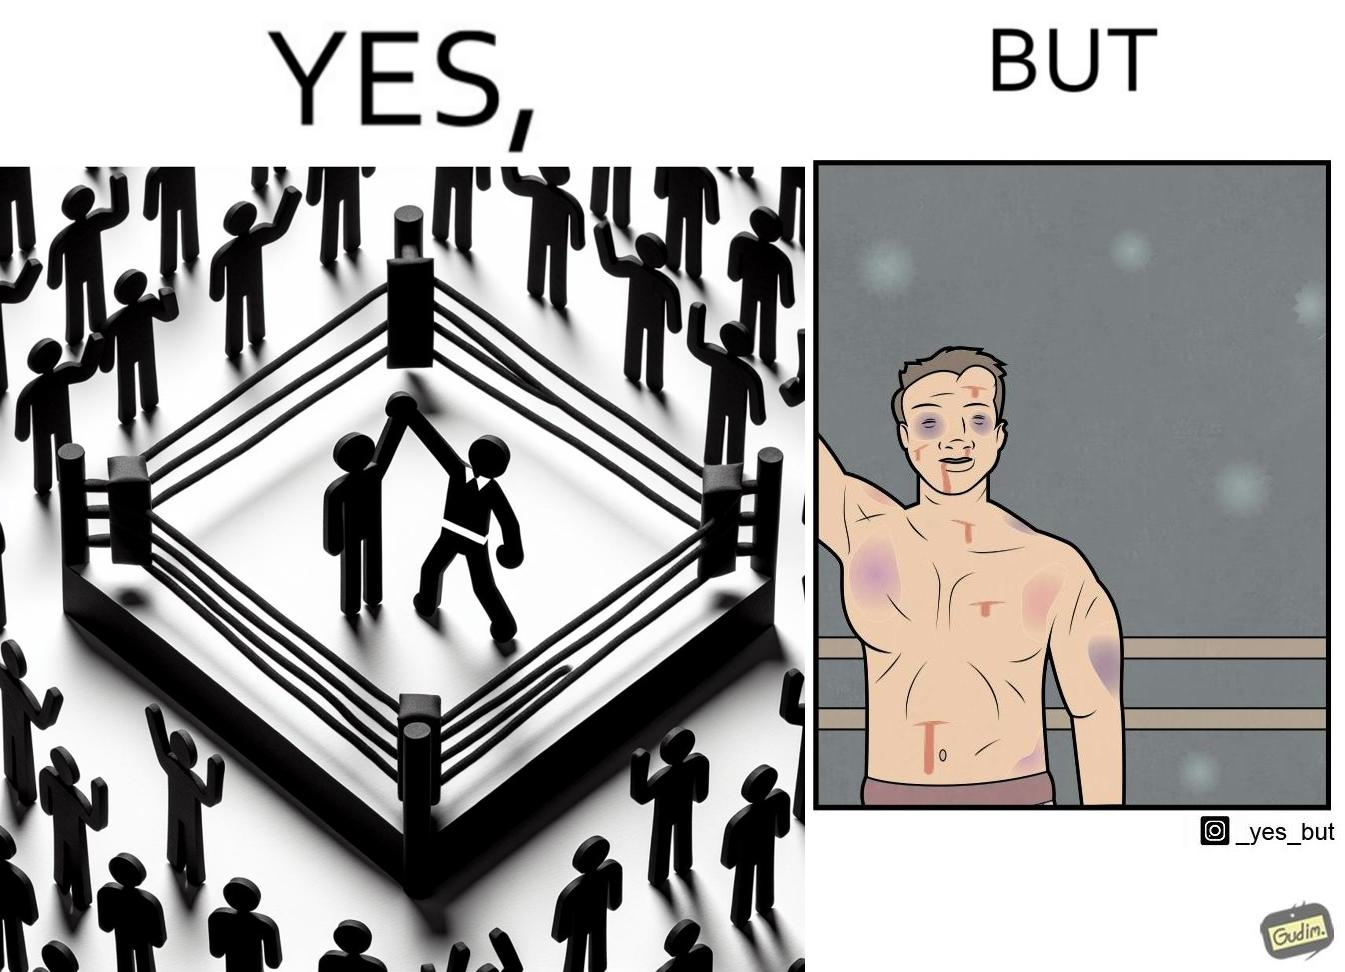What do you see in each half of this image? In the left part of the image: a referee announcing the winner of a boxing match. In the right part of the image: a bruised boxer. 